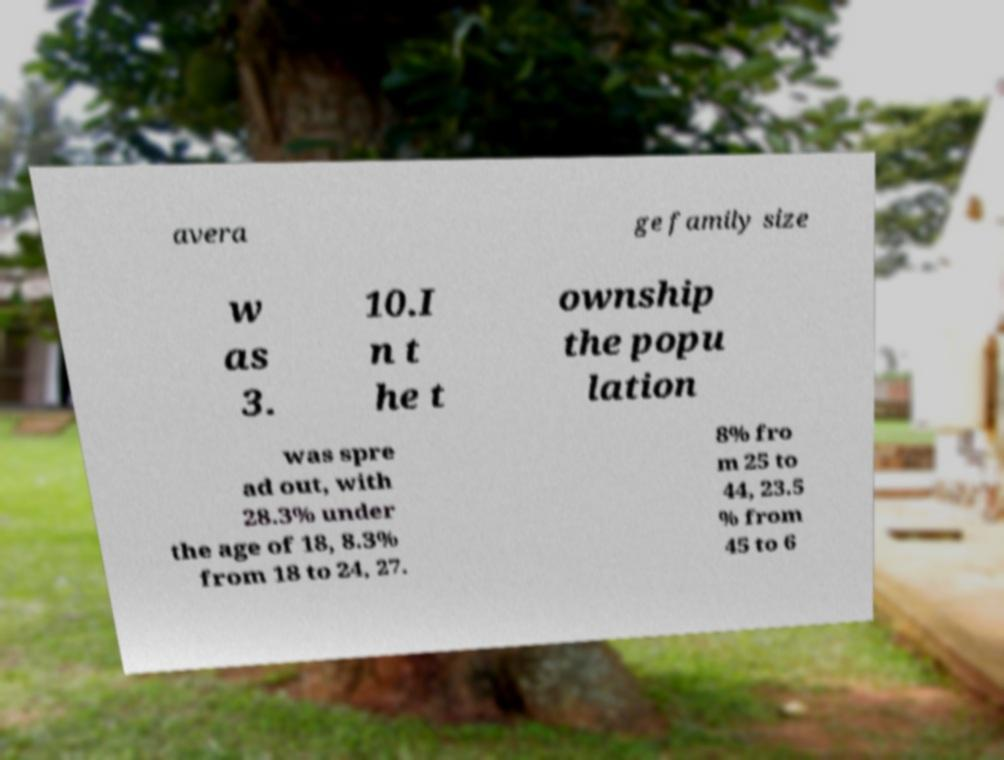Could you extract and type out the text from this image? avera ge family size w as 3. 10.I n t he t ownship the popu lation was spre ad out, with 28.3% under the age of 18, 8.3% from 18 to 24, 27. 8% fro m 25 to 44, 23.5 % from 45 to 6 